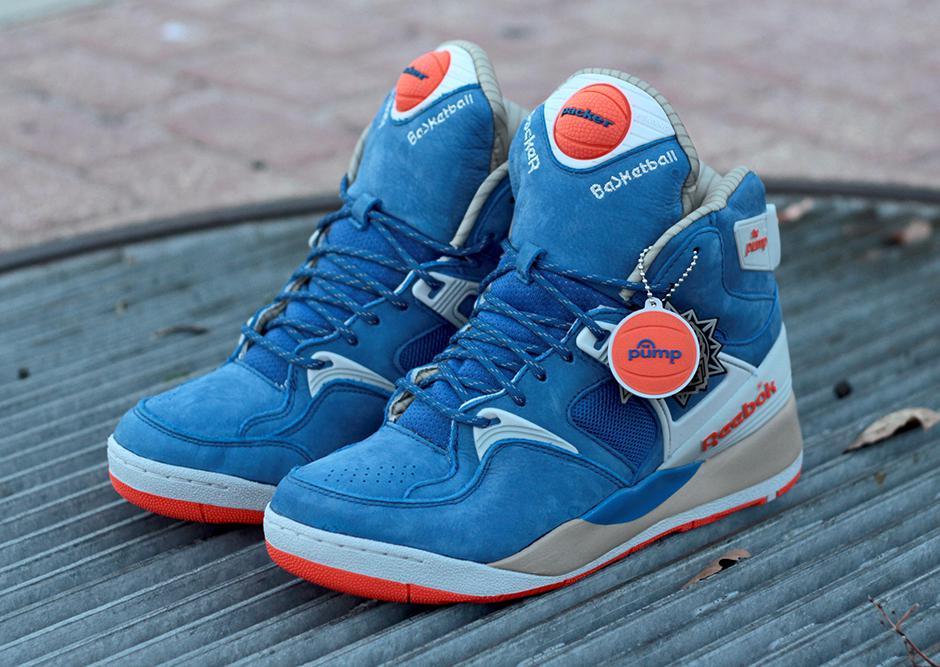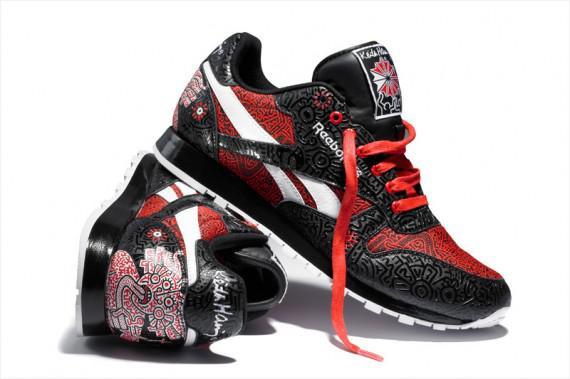The first image is the image on the left, the second image is the image on the right. For the images shown, is this caption "There is at least one blue sneaker" true? Answer yes or no. Yes. The first image is the image on the left, the second image is the image on the right. Assess this claim about the two images: "A total of four sneakers are shown in the images.". Correct or not? Answer yes or no. Yes. 